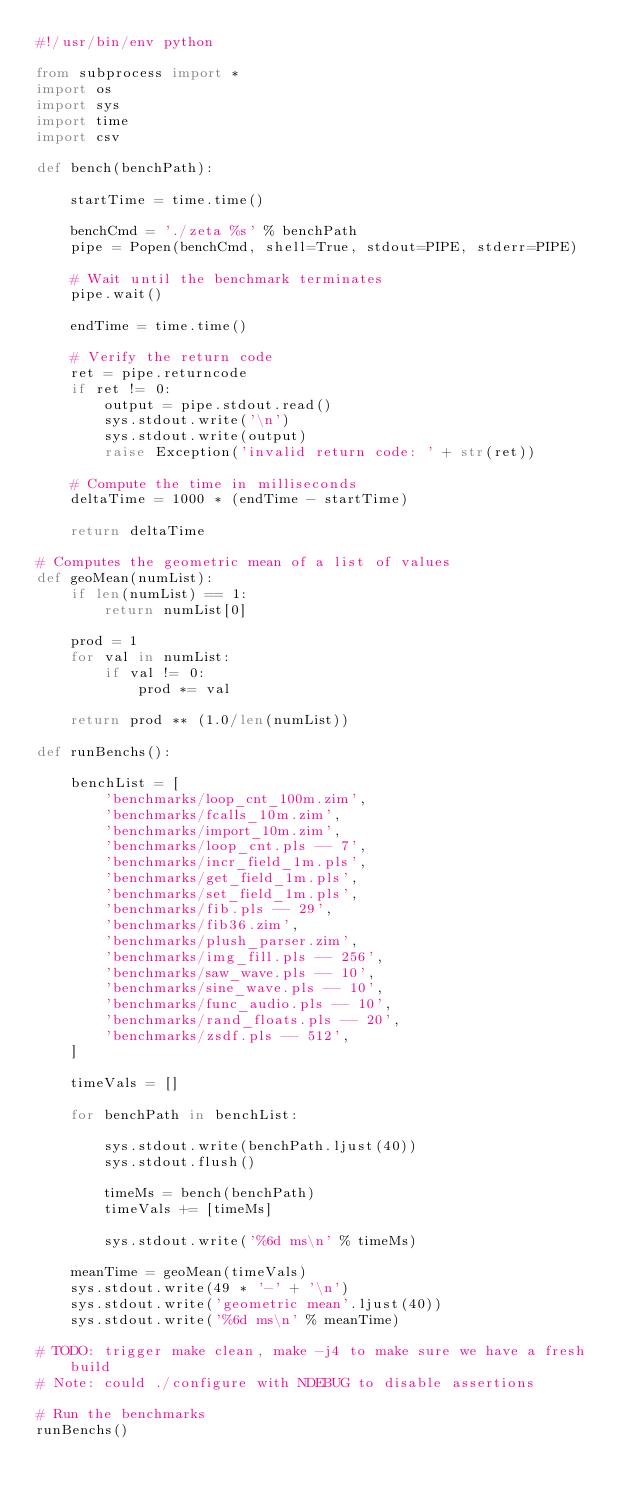Convert code to text. <code><loc_0><loc_0><loc_500><loc_500><_Python_>#!/usr/bin/env python

from subprocess import *
import os
import sys
import time
import csv

def bench(benchPath):

    startTime = time.time()

    benchCmd = './zeta %s' % benchPath
    pipe = Popen(benchCmd, shell=True, stdout=PIPE, stderr=PIPE)

    # Wait until the benchmark terminates
    pipe.wait()

    endTime = time.time()

    # Verify the return code
    ret = pipe.returncode
    if ret != 0:
        output = pipe.stdout.read()
        sys.stdout.write('\n')
        sys.stdout.write(output)
        raise Exception('invalid return code: ' + str(ret))

    # Compute the time in milliseconds
    deltaTime = 1000 * (endTime - startTime)

    return deltaTime

# Computes the geometric mean of a list of values
def geoMean(numList):
    if len(numList) == 1:
        return numList[0]

    prod = 1
    for val in numList:
        if val != 0:
            prod *= val

    return prod ** (1.0/len(numList))

def runBenchs():

    benchList = [
        'benchmarks/loop_cnt_100m.zim',
        'benchmarks/fcalls_10m.zim',
        'benchmarks/import_10m.zim',
        'benchmarks/loop_cnt.pls -- 7',
        'benchmarks/incr_field_1m.pls',
        'benchmarks/get_field_1m.pls',
        'benchmarks/set_field_1m.pls',
        'benchmarks/fib.pls -- 29',
        'benchmarks/fib36.zim',
        'benchmarks/plush_parser.zim',
        'benchmarks/img_fill.pls -- 256',
        'benchmarks/saw_wave.pls -- 10',
        'benchmarks/sine_wave.pls -- 10',
        'benchmarks/func_audio.pls -- 10',
        'benchmarks/rand_floats.pls -- 20',
        'benchmarks/zsdf.pls -- 512',
    ]

    timeVals = []

    for benchPath in benchList:

        sys.stdout.write(benchPath.ljust(40))
        sys.stdout.flush()

        timeMs = bench(benchPath)
        timeVals += [timeMs]

        sys.stdout.write('%6d ms\n' % timeMs)

    meanTime = geoMean(timeVals)
    sys.stdout.write(49 * '-' + '\n')
    sys.stdout.write('geometric mean'.ljust(40))
    sys.stdout.write('%6d ms\n' % meanTime)

# TODO: trigger make clean, make -j4 to make sure we have a fresh build
# Note: could ./configure with NDEBUG to disable assertions

# Run the benchmarks
runBenchs()
</code> 